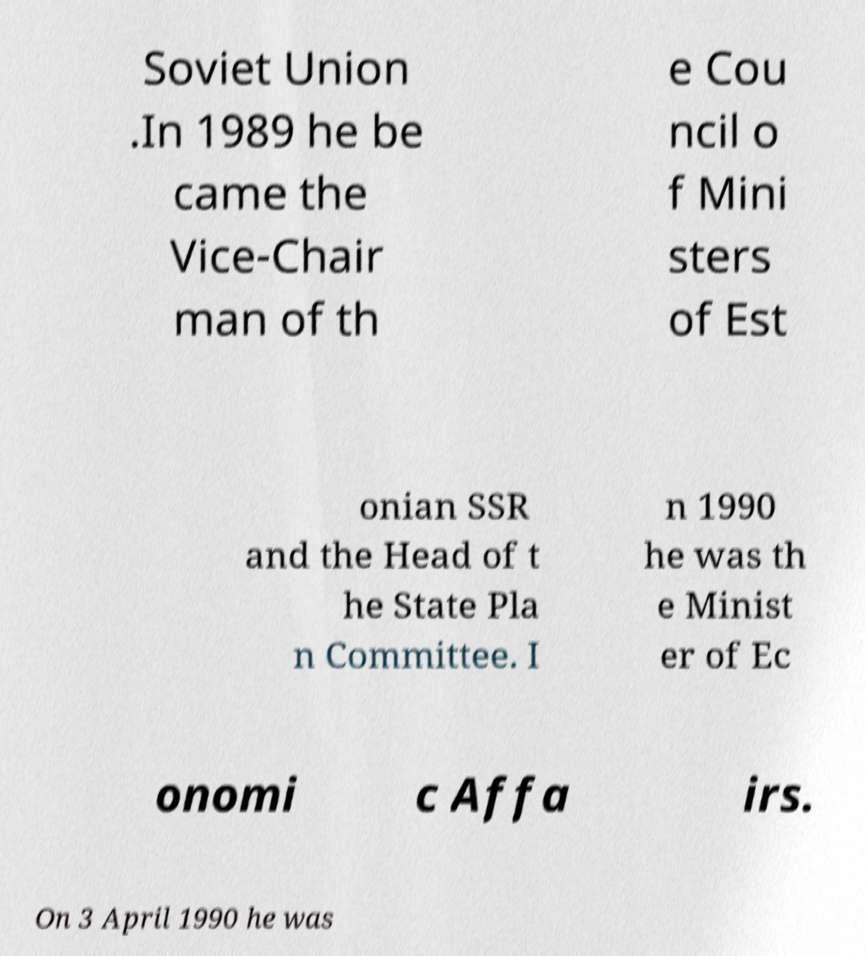Can you read and provide the text displayed in the image?This photo seems to have some interesting text. Can you extract and type it out for me? Soviet Union .In 1989 he be came the Vice-Chair man of th e Cou ncil o f Mini sters of Est onian SSR and the Head of t he State Pla n Committee. I n 1990 he was th e Minist er of Ec onomi c Affa irs. On 3 April 1990 he was 